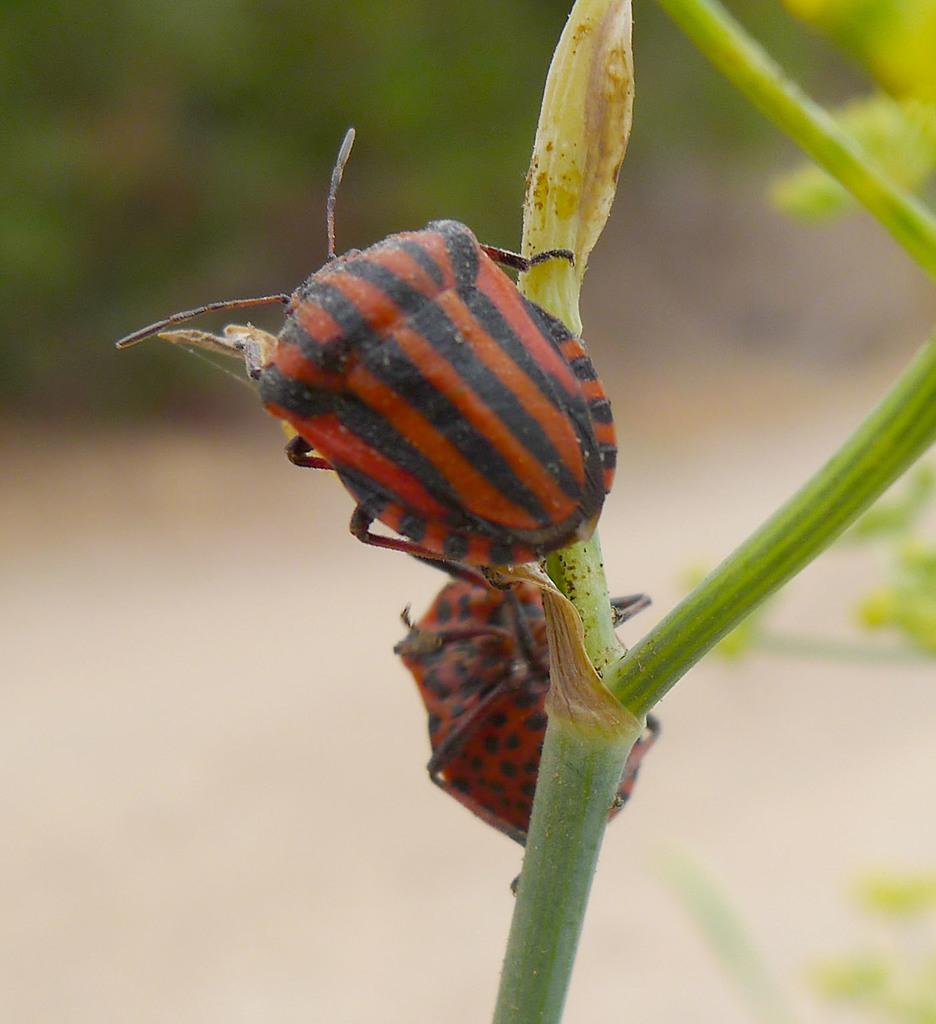What type of living organisms can be seen on the stem of a tree in the image? There are insects on the stem of a tree in the image. What type of desk can be seen in the image? There is no desk present in the image; it features insects on the stem of a tree. Is there a guitar being played by the insects in the image? There is no guitar or any musical instruments present in the image; it features insects on the stem of a tree. 